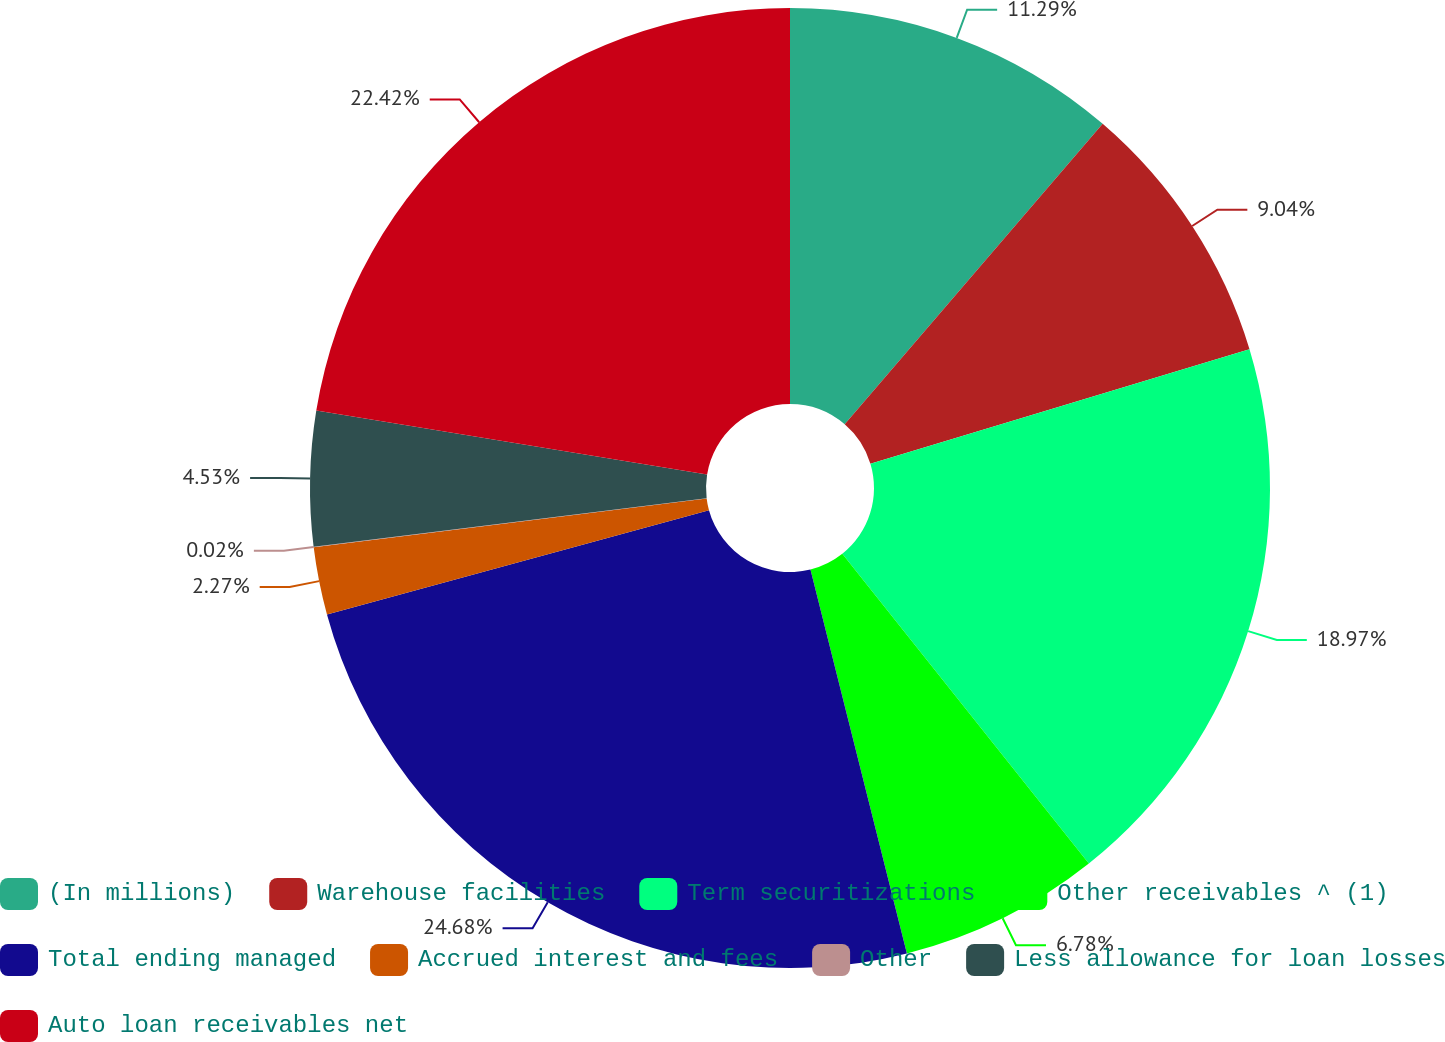<chart> <loc_0><loc_0><loc_500><loc_500><pie_chart><fcel>(In millions)<fcel>Warehouse facilities<fcel>Term securitizations<fcel>Other receivables ^ (1)<fcel>Total ending managed<fcel>Accrued interest and fees<fcel>Other<fcel>Less allowance for loan losses<fcel>Auto loan receivables net<nl><fcel>11.29%<fcel>9.04%<fcel>18.97%<fcel>6.78%<fcel>24.67%<fcel>2.27%<fcel>0.02%<fcel>4.53%<fcel>22.42%<nl></chart> 